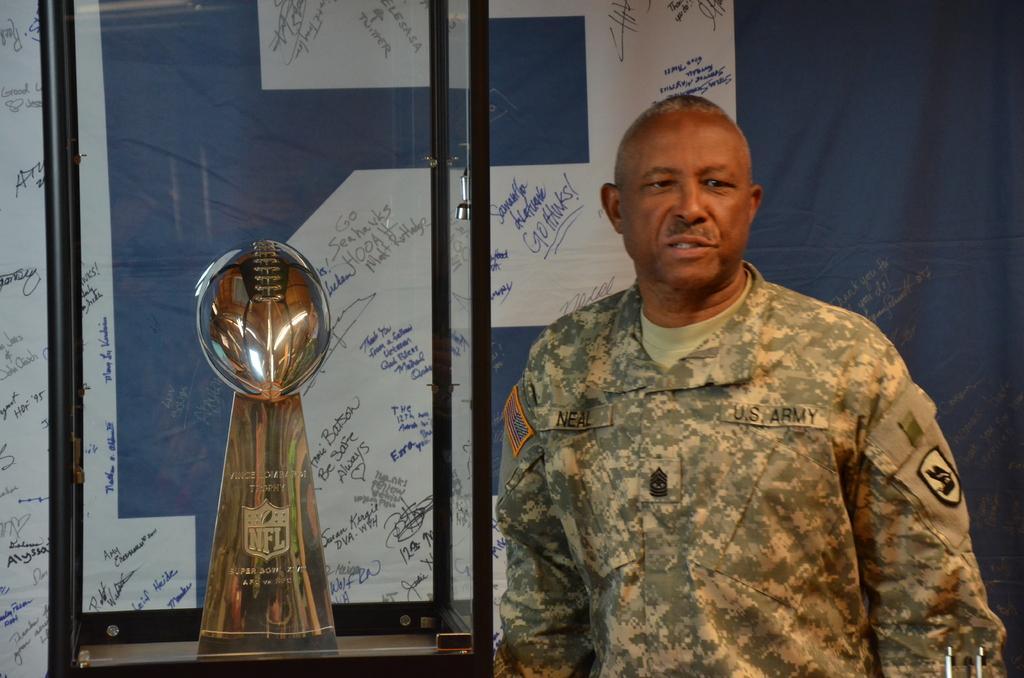Can you describe this image briefly? In this picture there is a soldier standing and there is an award beside him which is placed in a glass container and there is a banner behind him which has something written on it. 